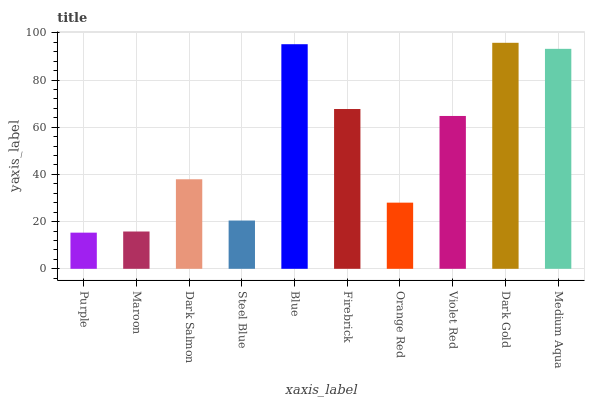Is Purple the minimum?
Answer yes or no. Yes. Is Dark Gold the maximum?
Answer yes or no. Yes. Is Maroon the minimum?
Answer yes or no. No. Is Maroon the maximum?
Answer yes or no. No. Is Maroon greater than Purple?
Answer yes or no. Yes. Is Purple less than Maroon?
Answer yes or no. Yes. Is Purple greater than Maroon?
Answer yes or no. No. Is Maroon less than Purple?
Answer yes or no. No. Is Violet Red the high median?
Answer yes or no. Yes. Is Dark Salmon the low median?
Answer yes or no. Yes. Is Orange Red the high median?
Answer yes or no. No. Is Firebrick the low median?
Answer yes or no. No. 